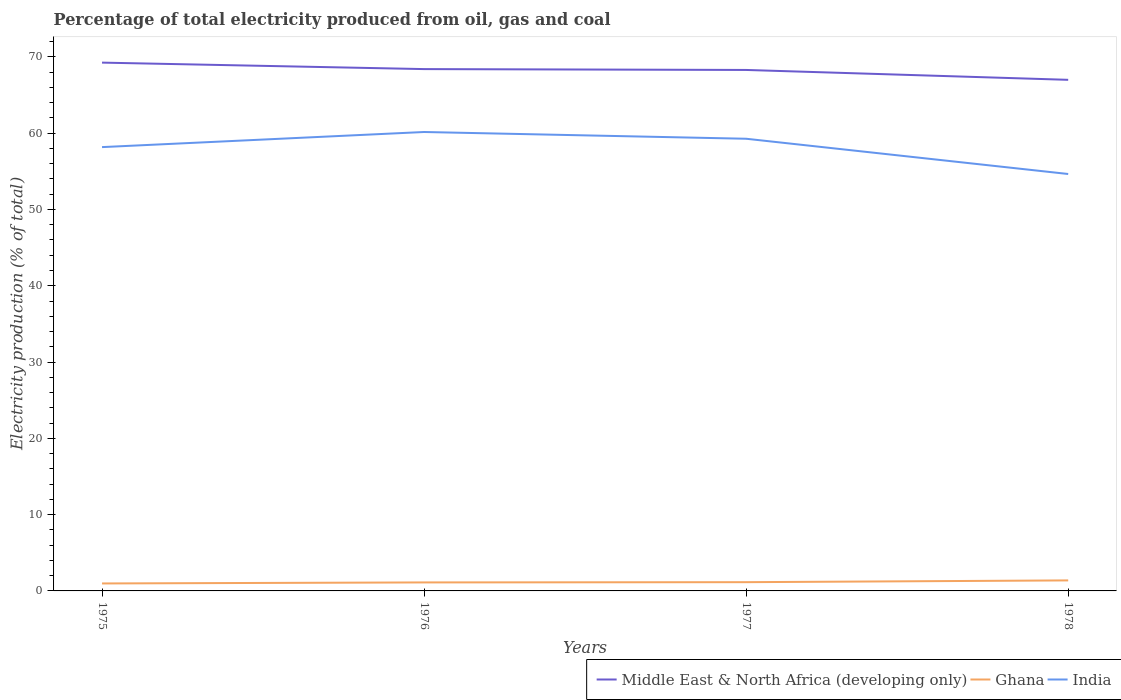Does the line corresponding to Middle East & North Africa (developing only) intersect with the line corresponding to Ghana?
Provide a succinct answer. No. Is the number of lines equal to the number of legend labels?
Ensure brevity in your answer.  Yes. Across all years, what is the maximum electricity production in in Middle East & North Africa (developing only)?
Your answer should be compact. 67. In which year was the electricity production in in Middle East & North Africa (developing only) maximum?
Your answer should be compact. 1978. What is the total electricity production in in Ghana in the graph?
Provide a short and direct response. -0.03. What is the difference between the highest and the second highest electricity production in in Middle East & North Africa (developing only)?
Provide a short and direct response. 2.26. How many lines are there?
Your answer should be compact. 3. How many years are there in the graph?
Your answer should be compact. 4. Does the graph contain any zero values?
Your answer should be compact. No. How many legend labels are there?
Offer a terse response. 3. What is the title of the graph?
Your response must be concise. Percentage of total electricity produced from oil, gas and coal. Does "Kazakhstan" appear as one of the legend labels in the graph?
Make the answer very short. No. What is the label or title of the Y-axis?
Provide a short and direct response. Electricity production (% of total). What is the Electricity production (% of total) in Middle East & North Africa (developing only) in 1975?
Give a very brief answer. 69.25. What is the Electricity production (% of total) in Ghana in 1975?
Offer a terse response. 0.98. What is the Electricity production (% of total) in India in 1975?
Keep it short and to the point. 58.18. What is the Electricity production (% of total) in Middle East & North Africa (developing only) in 1976?
Provide a short and direct response. 68.4. What is the Electricity production (% of total) in Ghana in 1976?
Your response must be concise. 1.11. What is the Electricity production (% of total) in India in 1976?
Offer a very short reply. 60.16. What is the Electricity production (% of total) in Middle East & North Africa (developing only) in 1977?
Give a very brief answer. 68.29. What is the Electricity production (% of total) in Ghana in 1977?
Keep it short and to the point. 1.15. What is the Electricity production (% of total) of India in 1977?
Your answer should be compact. 59.27. What is the Electricity production (% of total) of Middle East & North Africa (developing only) in 1978?
Ensure brevity in your answer.  67. What is the Electricity production (% of total) of Ghana in 1978?
Keep it short and to the point. 1.38. What is the Electricity production (% of total) in India in 1978?
Ensure brevity in your answer.  54.65. Across all years, what is the maximum Electricity production (% of total) in Middle East & North Africa (developing only)?
Keep it short and to the point. 69.25. Across all years, what is the maximum Electricity production (% of total) in Ghana?
Offer a terse response. 1.38. Across all years, what is the maximum Electricity production (% of total) in India?
Your response must be concise. 60.16. Across all years, what is the minimum Electricity production (% of total) of Middle East & North Africa (developing only)?
Your answer should be compact. 67. Across all years, what is the minimum Electricity production (% of total) in Ghana?
Provide a succinct answer. 0.98. Across all years, what is the minimum Electricity production (% of total) of India?
Your answer should be very brief. 54.65. What is the total Electricity production (% of total) in Middle East & North Africa (developing only) in the graph?
Ensure brevity in your answer.  272.94. What is the total Electricity production (% of total) in Ghana in the graph?
Give a very brief answer. 4.62. What is the total Electricity production (% of total) of India in the graph?
Keep it short and to the point. 232.26. What is the difference between the Electricity production (% of total) of Middle East & North Africa (developing only) in 1975 and that in 1976?
Provide a short and direct response. 0.85. What is the difference between the Electricity production (% of total) of Ghana in 1975 and that in 1976?
Offer a terse response. -0.14. What is the difference between the Electricity production (% of total) of India in 1975 and that in 1976?
Provide a succinct answer. -1.98. What is the difference between the Electricity production (% of total) of Middle East & North Africa (developing only) in 1975 and that in 1977?
Your answer should be very brief. 0.96. What is the difference between the Electricity production (% of total) of Ghana in 1975 and that in 1977?
Make the answer very short. -0.17. What is the difference between the Electricity production (% of total) of India in 1975 and that in 1977?
Your answer should be very brief. -1.1. What is the difference between the Electricity production (% of total) of Middle East & North Africa (developing only) in 1975 and that in 1978?
Make the answer very short. 2.26. What is the difference between the Electricity production (% of total) in Ghana in 1975 and that in 1978?
Offer a very short reply. -0.4. What is the difference between the Electricity production (% of total) in India in 1975 and that in 1978?
Provide a succinct answer. 3.53. What is the difference between the Electricity production (% of total) of Middle East & North Africa (developing only) in 1976 and that in 1977?
Your response must be concise. 0.11. What is the difference between the Electricity production (% of total) in Ghana in 1976 and that in 1977?
Make the answer very short. -0.03. What is the difference between the Electricity production (% of total) of India in 1976 and that in 1977?
Provide a succinct answer. 0.88. What is the difference between the Electricity production (% of total) of Middle East & North Africa (developing only) in 1976 and that in 1978?
Keep it short and to the point. 1.41. What is the difference between the Electricity production (% of total) in Ghana in 1976 and that in 1978?
Ensure brevity in your answer.  -0.26. What is the difference between the Electricity production (% of total) of India in 1976 and that in 1978?
Keep it short and to the point. 5.51. What is the difference between the Electricity production (% of total) in Middle East & North Africa (developing only) in 1977 and that in 1978?
Keep it short and to the point. 1.29. What is the difference between the Electricity production (% of total) in Ghana in 1977 and that in 1978?
Provide a succinct answer. -0.23. What is the difference between the Electricity production (% of total) in India in 1977 and that in 1978?
Your answer should be very brief. 4.62. What is the difference between the Electricity production (% of total) of Middle East & North Africa (developing only) in 1975 and the Electricity production (% of total) of Ghana in 1976?
Your answer should be very brief. 68.14. What is the difference between the Electricity production (% of total) of Middle East & North Africa (developing only) in 1975 and the Electricity production (% of total) of India in 1976?
Keep it short and to the point. 9.09. What is the difference between the Electricity production (% of total) of Ghana in 1975 and the Electricity production (% of total) of India in 1976?
Offer a very short reply. -59.18. What is the difference between the Electricity production (% of total) of Middle East & North Africa (developing only) in 1975 and the Electricity production (% of total) of Ghana in 1977?
Your answer should be compact. 68.1. What is the difference between the Electricity production (% of total) in Middle East & North Africa (developing only) in 1975 and the Electricity production (% of total) in India in 1977?
Keep it short and to the point. 9.98. What is the difference between the Electricity production (% of total) of Ghana in 1975 and the Electricity production (% of total) of India in 1977?
Your response must be concise. -58.29. What is the difference between the Electricity production (% of total) in Middle East & North Africa (developing only) in 1975 and the Electricity production (% of total) in Ghana in 1978?
Keep it short and to the point. 67.87. What is the difference between the Electricity production (% of total) in Middle East & North Africa (developing only) in 1975 and the Electricity production (% of total) in India in 1978?
Your answer should be compact. 14.6. What is the difference between the Electricity production (% of total) of Ghana in 1975 and the Electricity production (% of total) of India in 1978?
Provide a short and direct response. -53.67. What is the difference between the Electricity production (% of total) of Middle East & North Africa (developing only) in 1976 and the Electricity production (% of total) of Ghana in 1977?
Keep it short and to the point. 67.26. What is the difference between the Electricity production (% of total) in Middle East & North Africa (developing only) in 1976 and the Electricity production (% of total) in India in 1977?
Give a very brief answer. 9.13. What is the difference between the Electricity production (% of total) in Ghana in 1976 and the Electricity production (% of total) in India in 1977?
Your answer should be very brief. -58.16. What is the difference between the Electricity production (% of total) in Middle East & North Africa (developing only) in 1976 and the Electricity production (% of total) in Ghana in 1978?
Give a very brief answer. 67.03. What is the difference between the Electricity production (% of total) in Middle East & North Africa (developing only) in 1976 and the Electricity production (% of total) in India in 1978?
Make the answer very short. 13.75. What is the difference between the Electricity production (% of total) in Ghana in 1976 and the Electricity production (% of total) in India in 1978?
Give a very brief answer. -53.54. What is the difference between the Electricity production (% of total) of Middle East & North Africa (developing only) in 1977 and the Electricity production (% of total) of Ghana in 1978?
Provide a short and direct response. 66.91. What is the difference between the Electricity production (% of total) of Middle East & North Africa (developing only) in 1977 and the Electricity production (% of total) of India in 1978?
Provide a succinct answer. 13.64. What is the difference between the Electricity production (% of total) in Ghana in 1977 and the Electricity production (% of total) in India in 1978?
Offer a very short reply. -53.5. What is the average Electricity production (% of total) of Middle East & North Africa (developing only) per year?
Your response must be concise. 68.23. What is the average Electricity production (% of total) of Ghana per year?
Your answer should be compact. 1.15. What is the average Electricity production (% of total) of India per year?
Make the answer very short. 58.06. In the year 1975, what is the difference between the Electricity production (% of total) in Middle East & North Africa (developing only) and Electricity production (% of total) in Ghana?
Provide a succinct answer. 68.27. In the year 1975, what is the difference between the Electricity production (% of total) in Middle East & North Africa (developing only) and Electricity production (% of total) in India?
Make the answer very short. 11.07. In the year 1975, what is the difference between the Electricity production (% of total) of Ghana and Electricity production (% of total) of India?
Ensure brevity in your answer.  -57.2. In the year 1976, what is the difference between the Electricity production (% of total) of Middle East & North Africa (developing only) and Electricity production (% of total) of Ghana?
Provide a succinct answer. 67.29. In the year 1976, what is the difference between the Electricity production (% of total) of Middle East & North Africa (developing only) and Electricity production (% of total) of India?
Your answer should be compact. 8.25. In the year 1976, what is the difference between the Electricity production (% of total) in Ghana and Electricity production (% of total) in India?
Provide a succinct answer. -59.04. In the year 1977, what is the difference between the Electricity production (% of total) in Middle East & North Africa (developing only) and Electricity production (% of total) in Ghana?
Your answer should be very brief. 67.14. In the year 1977, what is the difference between the Electricity production (% of total) in Middle East & North Africa (developing only) and Electricity production (% of total) in India?
Offer a terse response. 9.02. In the year 1977, what is the difference between the Electricity production (% of total) in Ghana and Electricity production (% of total) in India?
Your answer should be very brief. -58.12. In the year 1978, what is the difference between the Electricity production (% of total) of Middle East & North Africa (developing only) and Electricity production (% of total) of Ghana?
Your answer should be compact. 65.62. In the year 1978, what is the difference between the Electricity production (% of total) of Middle East & North Africa (developing only) and Electricity production (% of total) of India?
Your response must be concise. 12.34. In the year 1978, what is the difference between the Electricity production (% of total) in Ghana and Electricity production (% of total) in India?
Provide a short and direct response. -53.27. What is the ratio of the Electricity production (% of total) of Middle East & North Africa (developing only) in 1975 to that in 1976?
Keep it short and to the point. 1.01. What is the ratio of the Electricity production (% of total) of Ghana in 1975 to that in 1976?
Ensure brevity in your answer.  0.88. What is the ratio of the Electricity production (% of total) of India in 1975 to that in 1976?
Your answer should be compact. 0.97. What is the ratio of the Electricity production (% of total) in Middle East & North Africa (developing only) in 1975 to that in 1977?
Your response must be concise. 1.01. What is the ratio of the Electricity production (% of total) in Ghana in 1975 to that in 1977?
Provide a short and direct response. 0.85. What is the ratio of the Electricity production (% of total) of India in 1975 to that in 1977?
Make the answer very short. 0.98. What is the ratio of the Electricity production (% of total) in Middle East & North Africa (developing only) in 1975 to that in 1978?
Offer a terse response. 1.03. What is the ratio of the Electricity production (% of total) in Ghana in 1975 to that in 1978?
Your answer should be very brief. 0.71. What is the ratio of the Electricity production (% of total) in India in 1975 to that in 1978?
Provide a succinct answer. 1.06. What is the ratio of the Electricity production (% of total) of Middle East & North Africa (developing only) in 1976 to that in 1977?
Your response must be concise. 1. What is the ratio of the Electricity production (% of total) in Ghana in 1976 to that in 1977?
Offer a very short reply. 0.97. What is the ratio of the Electricity production (% of total) in India in 1976 to that in 1977?
Give a very brief answer. 1.01. What is the ratio of the Electricity production (% of total) in Ghana in 1976 to that in 1978?
Provide a succinct answer. 0.81. What is the ratio of the Electricity production (% of total) in India in 1976 to that in 1978?
Keep it short and to the point. 1.1. What is the ratio of the Electricity production (% of total) of Middle East & North Africa (developing only) in 1977 to that in 1978?
Your answer should be compact. 1.02. What is the ratio of the Electricity production (% of total) in Ghana in 1977 to that in 1978?
Offer a terse response. 0.83. What is the ratio of the Electricity production (% of total) in India in 1977 to that in 1978?
Your answer should be compact. 1.08. What is the difference between the highest and the second highest Electricity production (% of total) in Middle East & North Africa (developing only)?
Offer a terse response. 0.85. What is the difference between the highest and the second highest Electricity production (% of total) of Ghana?
Offer a terse response. 0.23. What is the difference between the highest and the second highest Electricity production (% of total) in India?
Your answer should be very brief. 0.88. What is the difference between the highest and the lowest Electricity production (% of total) in Middle East & North Africa (developing only)?
Your answer should be compact. 2.26. What is the difference between the highest and the lowest Electricity production (% of total) in Ghana?
Your response must be concise. 0.4. What is the difference between the highest and the lowest Electricity production (% of total) in India?
Offer a very short reply. 5.51. 